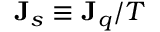<formula> <loc_0><loc_0><loc_500><loc_500>J _ { s } \equiv J _ { q } / T</formula> 